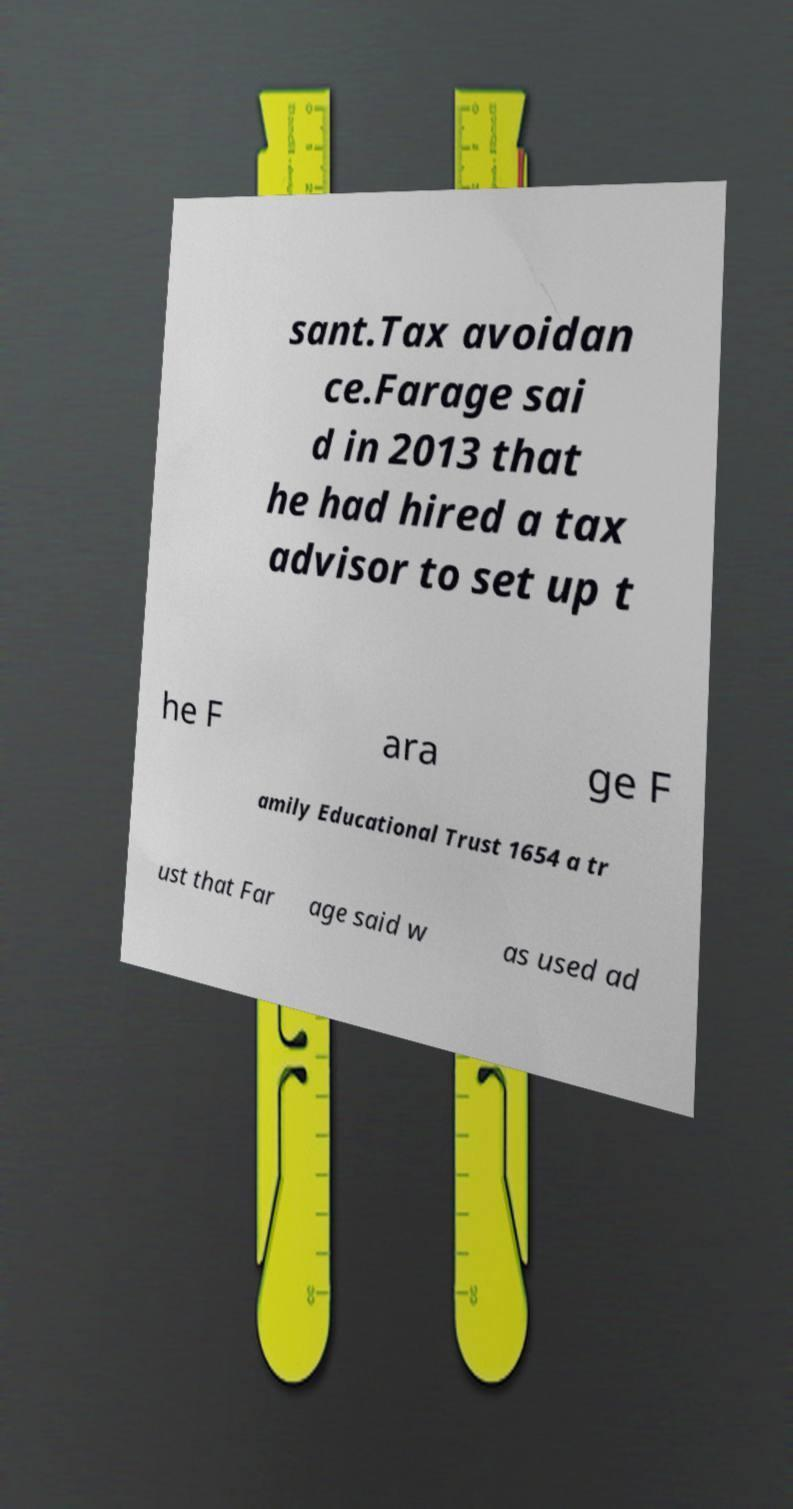Please identify and transcribe the text found in this image. sant.Tax avoidan ce.Farage sai d in 2013 that he had hired a tax advisor to set up t he F ara ge F amily Educational Trust 1654 a tr ust that Far age said w as used ad 